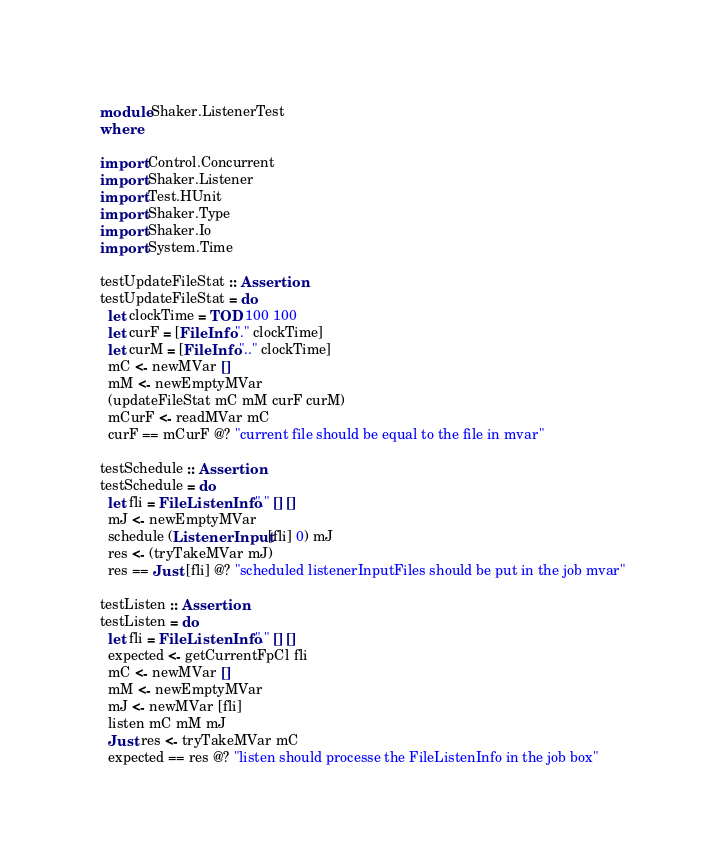Convert code to text. <code><loc_0><loc_0><loc_500><loc_500><_Haskell_>module Shaker.ListenerTest
where

import Control.Concurrent
import Shaker.Listener
import Test.HUnit 
import Shaker.Type
import Shaker.Io
import System.Time

testUpdateFileStat :: Assertion
testUpdateFileStat = do
  let clockTime = TOD 100 100
  let curF = [FileInfo "." clockTime]
  let curM = [FileInfo ".." clockTime]
  mC <- newMVar []
  mM <- newEmptyMVar 
  (updateFileStat mC mM curF curM) 
  mCurF <- readMVar mC
  curF == mCurF @? "current file should be equal to the file in mvar"

testSchedule :: Assertion
testSchedule = do
  let fli = FileListenInfo "." [] []
  mJ <- newEmptyMVar 
  schedule (ListenerInput [fli] 0) mJ
  res <- (tryTakeMVar mJ)
  res == Just [fli] @? "scheduled listenerInputFiles should be put in the job mvar"

testListen :: Assertion
testListen = do 
  let fli = FileListenInfo "." [] []
  expected <- getCurrentFpCl fli
  mC <- newMVar []
  mM <- newEmptyMVar 
  mJ <- newMVar [fli]
  listen mC mM mJ
  Just res <- tryTakeMVar mC
  expected == res @? "listen should processe the FileListenInfo in the job box"

</code> 